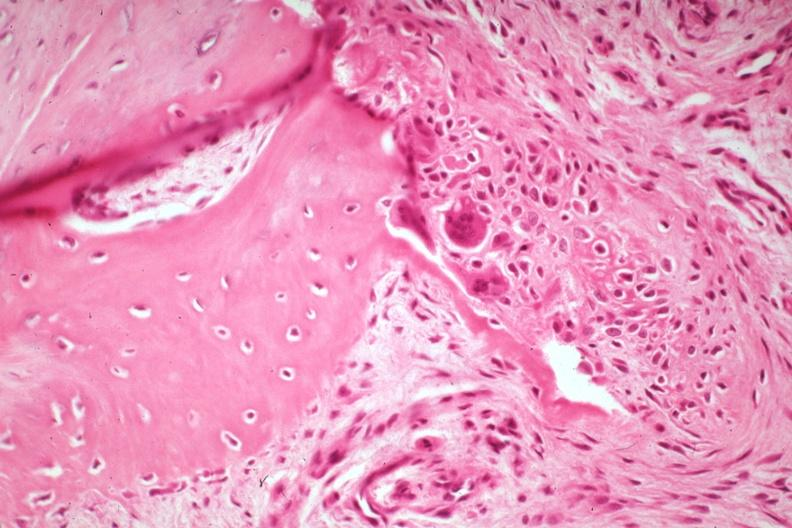what is present?
Answer the question using a single word or phrase. Joints 